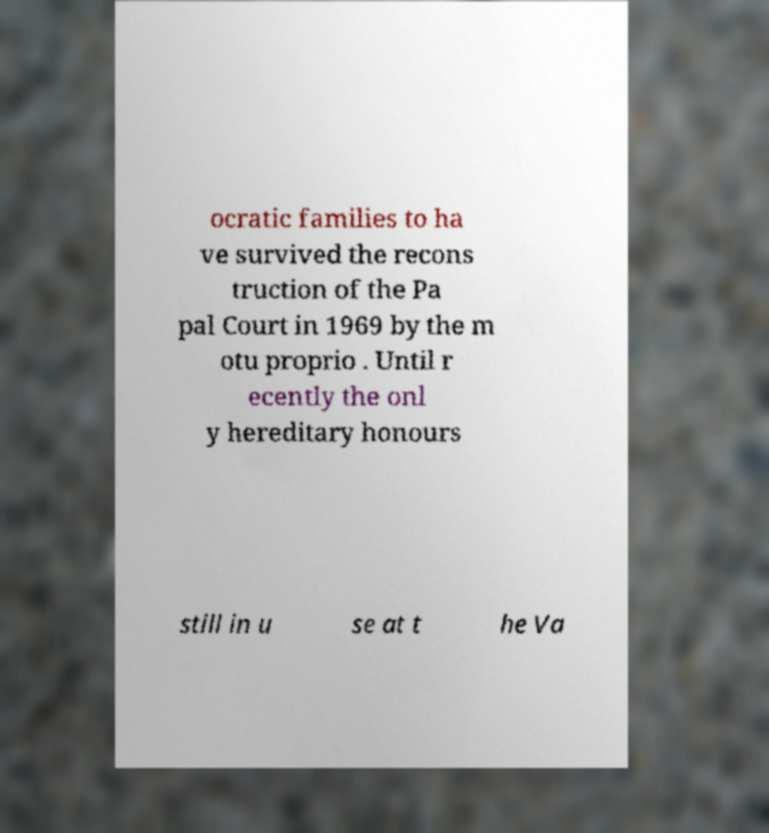Please identify and transcribe the text found in this image. ocratic families to ha ve survived the recons truction of the Pa pal Court in 1969 by the m otu proprio . Until r ecently the onl y hereditary honours still in u se at t he Va 